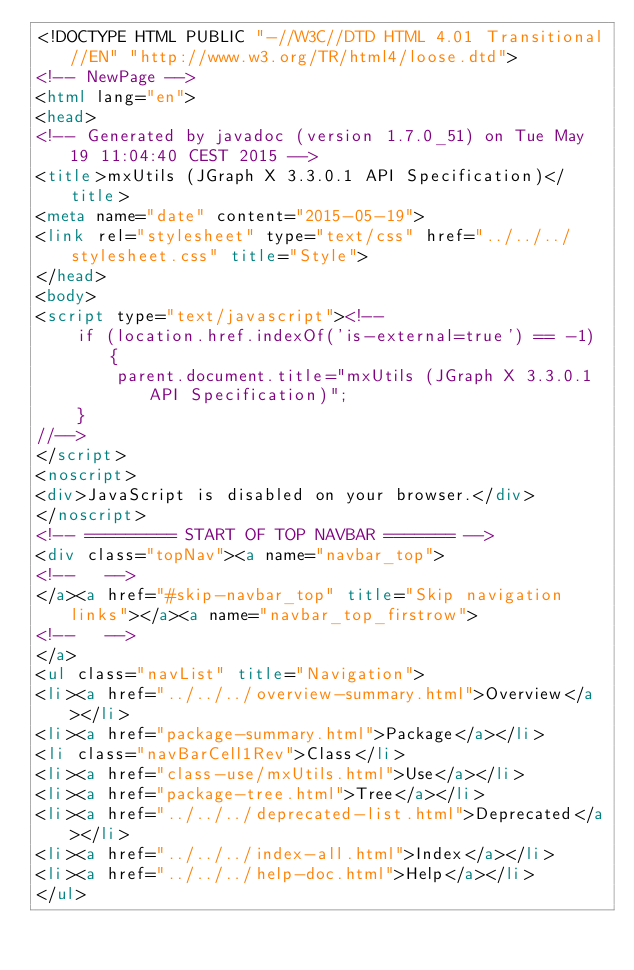Convert code to text. <code><loc_0><loc_0><loc_500><loc_500><_HTML_><!DOCTYPE HTML PUBLIC "-//W3C//DTD HTML 4.01 Transitional//EN" "http://www.w3.org/TR/html4/loose.dtd">
<!-- NewPage -->
<html lang="en">
<head>
<!-- Generated by javadoc (version 1.7.0_51) on Tue May 19 11:04:40 CEST 2015 -->
<title>mxUtils (JGraph X 3.3.0.1 API Specification)</title>
<meta name="date" content="2015-05-19">
<link rel="stylesheet" type="text/css" href="../../../stylesheet.css" title="Style">
</head>
<body>
<script type="text/javascript"><!--
    if (location.href.indexOf('is-external=true') == -1) {
        parent.document.title="mxUtils (JGraph X 3.3.0.1 API Specification)";
    }
//-->
</script>
<noscript>
<div>JavaScript is disabled on your browser.</div>
</noscript>
<!-- ========= START OF TOP NAVBAR ======= -->
<div class="topNav"><a name="navbar_top">
<!--   -->
</a><a href="#skip-navbar_top" title="Skip navigation links"></a><a name="navbar_top_firstrow">
<!--   -->
</a>
<ul class="navList" title="Navigation">
<li><a href="../../../overview-summary.html">Overview</a></li>
<li><a href="package-summary.html">Package</a></li>
<li class="navBarCell1Rev">Class</li>
<li><a href="class-use/mxUtils.html">Use</a></li>
<li><a href="package-tree.html">Tree</a></li>
<li><a href="../../../deprecated-list.html">Deprecated</a></li>
<li><a href="../../../index-all.html">Index</a></li>
<li><a href="../../../help-doc.html">Help</a></li>
</ul></code> 